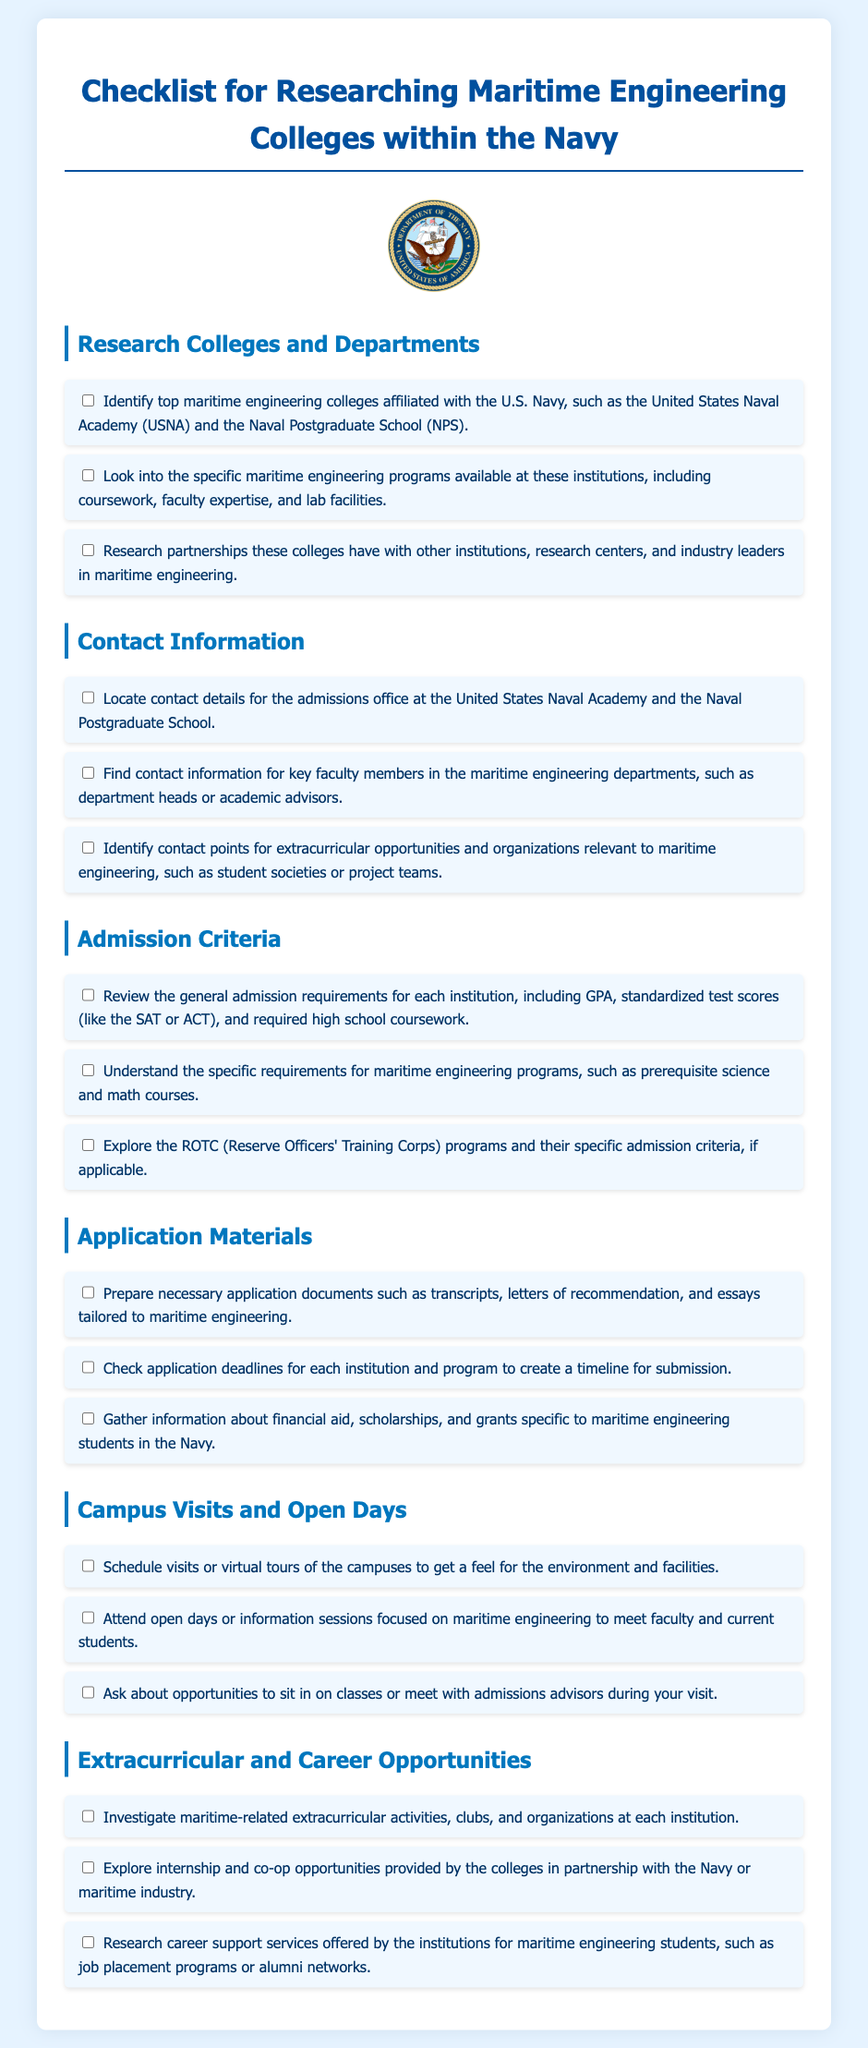What are the top colleges associated with the Navy? The document mentions top maritime engineering colleges affiliated with the U.S. Navy, specifically the United States Naval Academy and the Naval Postgraduate School.
Answer: United States Naval Academy, Naval Postgraduate School What specific programs should I research? The document suggests looking into the specific maritime engineering programs available, including coursework, faculty expertise, and lab facilities.
Answer: Coursework, faculty expertise, lab facilities What general admission requirements are listed? The document states that general admission requirements include GPA, standardized test scores (like the SAT or ACT), and required high school coursework.
Answer: GPA, standardized test scores, required high school coursework What is one of the ROTC program criteria? The checklist refers to exploring the specific admission criteria for ROTC programs related to maritime engineering.
Answer: Specific admission criteria for ROTC programs How many institutions are highlighted in this document? The document highlights two main institutions for maritime engineering within the Navy.
Answer: Two What extracurricular activities should I investigate? The document emphasizes investigating maritime-related extracurricular activities, clubs, and organizations at each institution.
Answer: Maritime-related extracurricular activities, clubs, organizations What materials need to be prepared for application? The document specifies that necessary application documents include transcripts, letters of recommendation, and essays tailored to maritime engineering.
Answer: Transcripts, letters of recommendation, essays When should I check application deadlines? The document advises checking application deadlines for each institution and program to create a timeline for submission.
Answer: Application deadlines What opportunities are provided in internship and co-op? The checklist mentions exploring internship and co-op opportunities provided by the colleges in partnership with the Navy or maritime industry.
Answer: Internship and co-op opportunities 